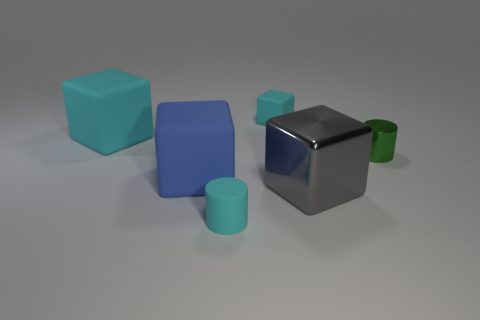There is a metallic object in front of the small green metal thing; how big is it?
Your response must be concise. Large. What is the material of the blue block?
Your answer should be very brief. Rubber. What number of objects are rubber cubes in front of the green metallic thing or blue things left of the gray metal thing?
Make the answer very short. 1. What number of other objects are the same color as the metallic cylinder?
Your answer should be very brief. 0. There is a small metal object; is it the same shape as the object in front of the large gray cube?
Your answer should be compact. Yes. Are there fewer big cubes that are left of the tiny cyan rubber block than matte cylinders to the left of the cyan cylinder?
Your response must be concise. No. There is a large gray object that is the same shape as the blue matte thing; what is it made of?
Your answer should be compact. Metal. Are there any other things that have the same material as the large blue cube?
Provide a succinct answer. Yes. Is the color of the tiny matte block the same as the rubber cylinder?
Keep it short and to the point. Yes. There is a small thing that is made of the same material as the small block; what shape is it?
Your answer should be very brief. Cylinder. 